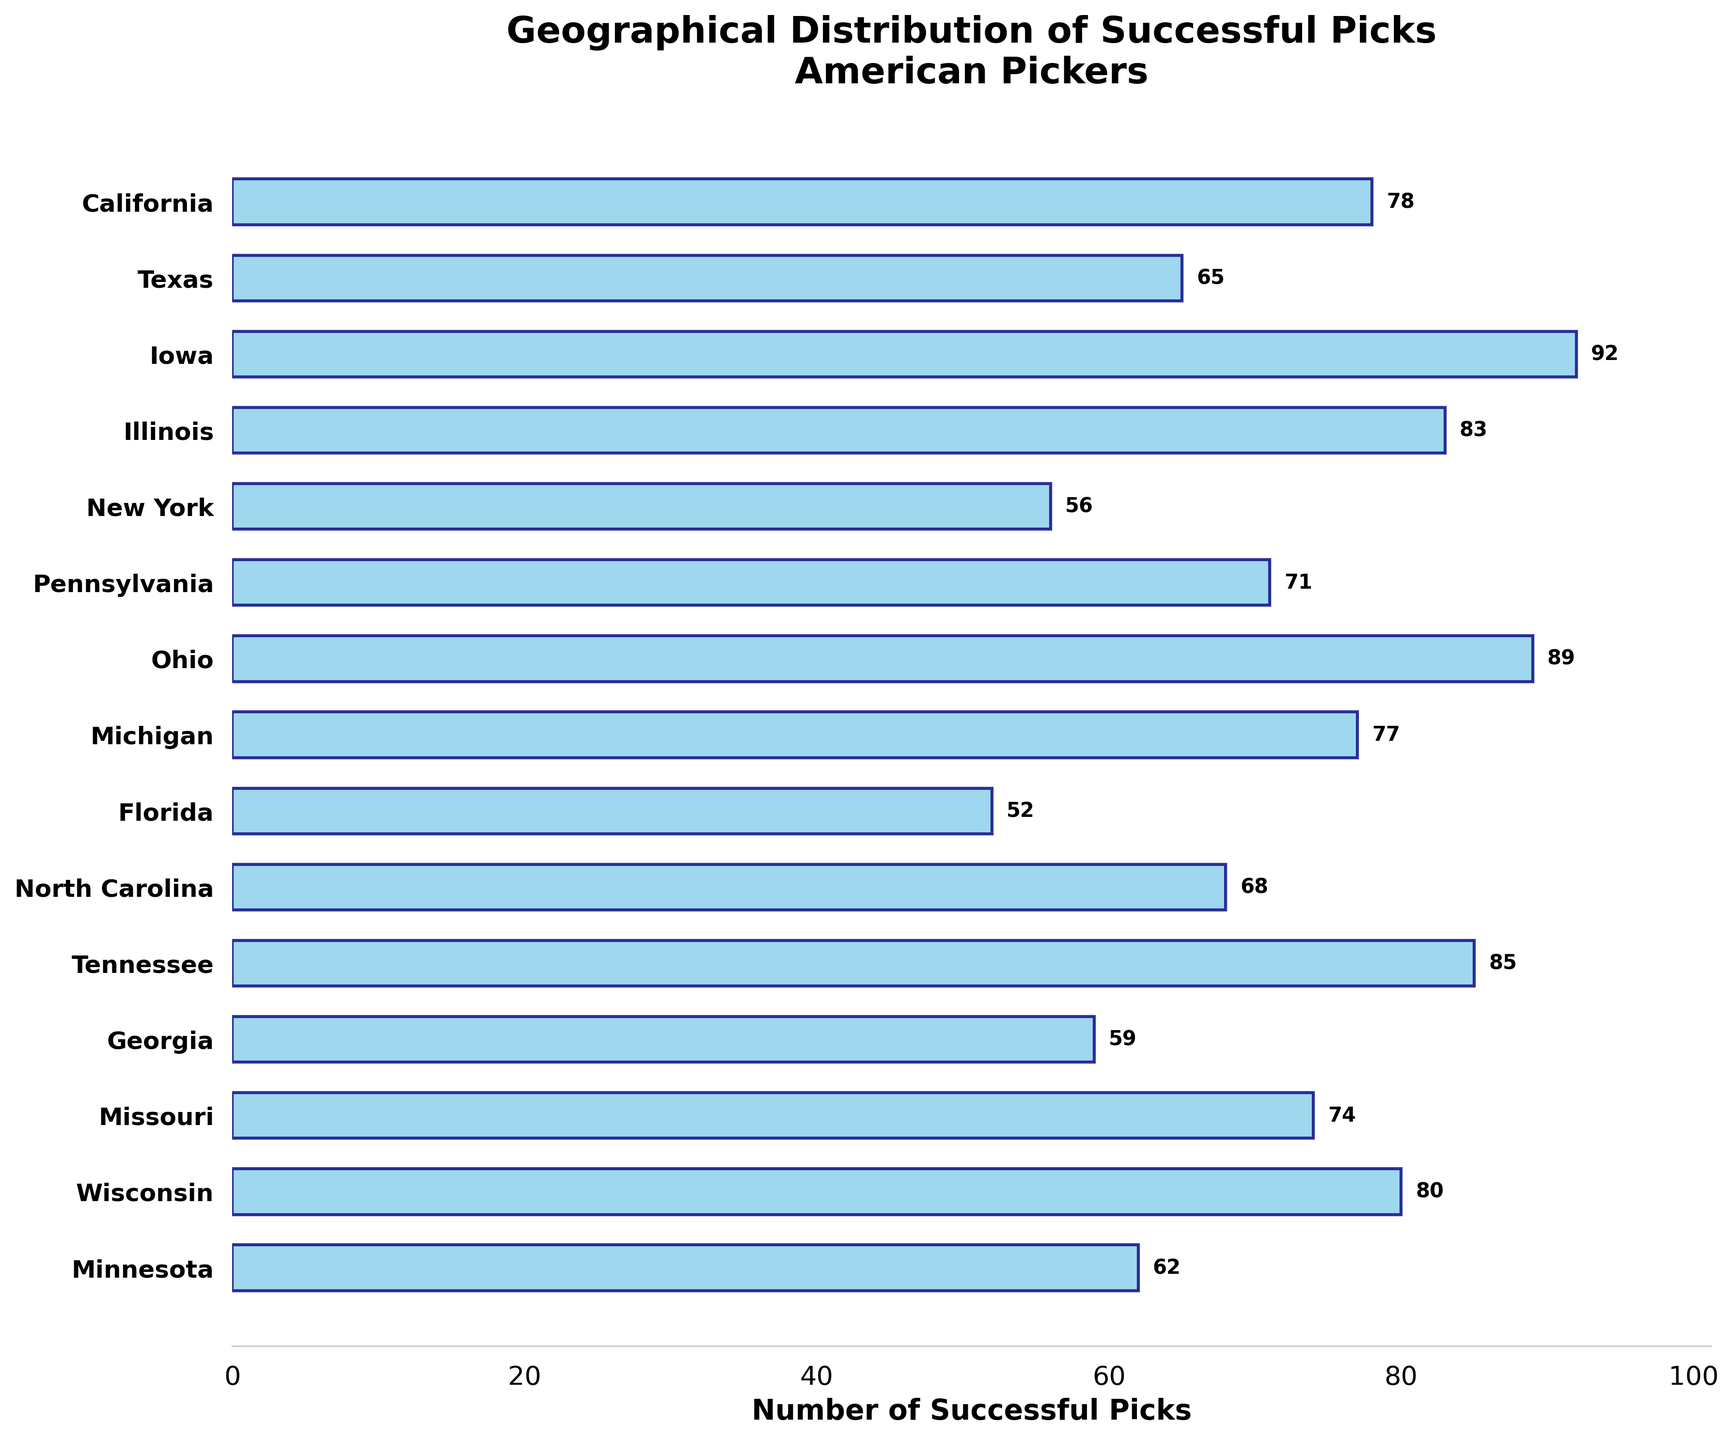Which state has the highest number of successful picks? To determine the state with the highest number of successful picks, look for the bar with the greatest length. The longest bar corresponds to Iowa with 92 successful picks.
Answer: Iowa What is the title of the figure? The title of the figure is displayed at the top in bold text. It reads "Geographical Distribution of Successful Picks\nAmerican Pickers".
Answer: Geographical Distribution of Successful Picks\nAmerican Pickers How many successful picks are there in Florida? To find the number of successful picks in Florida, locate the bar labeled 'Florida' and read the value associated with it. It has 52 successful picks.
Answer: 52 Which state has fewer successful picks, New York or Georgia? Compare the length of the bars for New York and Georgia. New York has 56 successful picks, while Georgia has 59. So, New York has fewer successful picks.
Answer: New York What is the combined total of successful picks for Iowa and Illinois? Sum the values for Iowa and Illinois. Iowa has 92 successful picks, and Illinois has 83. Therefore, 92 + 83 = 175.
Answer: 175 How many states have more than 80 successful picks? Count the number of bars that exceed the 80 successful picks mark. Iowa (92), Illinois (83), Ohio (89), Tennessee (85), and Wisconsin (80) meet this criterion.
Answer: 5 What is the average number of successful picks across all states shown? To find the average, sum all the successful picks and divide by the number of states. The total number of picks is 78 + 65 + 92 + 83 + 56 + 71 + 89 + 77 + 52 + 68 + 85 + 59 + 74 + 80 + 62 = 1011. There are 15 states. The average is 1011 / 15 ≈ 67.4.
Answer: 67.4 Which state has the second-highest number of successful picks? Identify the state with the second-longest bar. The longest is Iowa with 92, and the second-longest is Tennessee with 85.
Answer: Tennessee Are there more successful picks in Michigan or North Carolina? Compare the values for Michigan and North Carolina. Michigan has 77 successful picks, while North Carolina has 68. Therefore, Michigan has more successful picks.
Answer: Michigan What is the difference in successful picks between the state with the most and least picks? Subtract the value of the state with the least picks from the value of the state with the most picks. Iowa has the most with 92, and Florida has the least with 52. Therefore, 92 - 52 = 40.
Answer: 40 